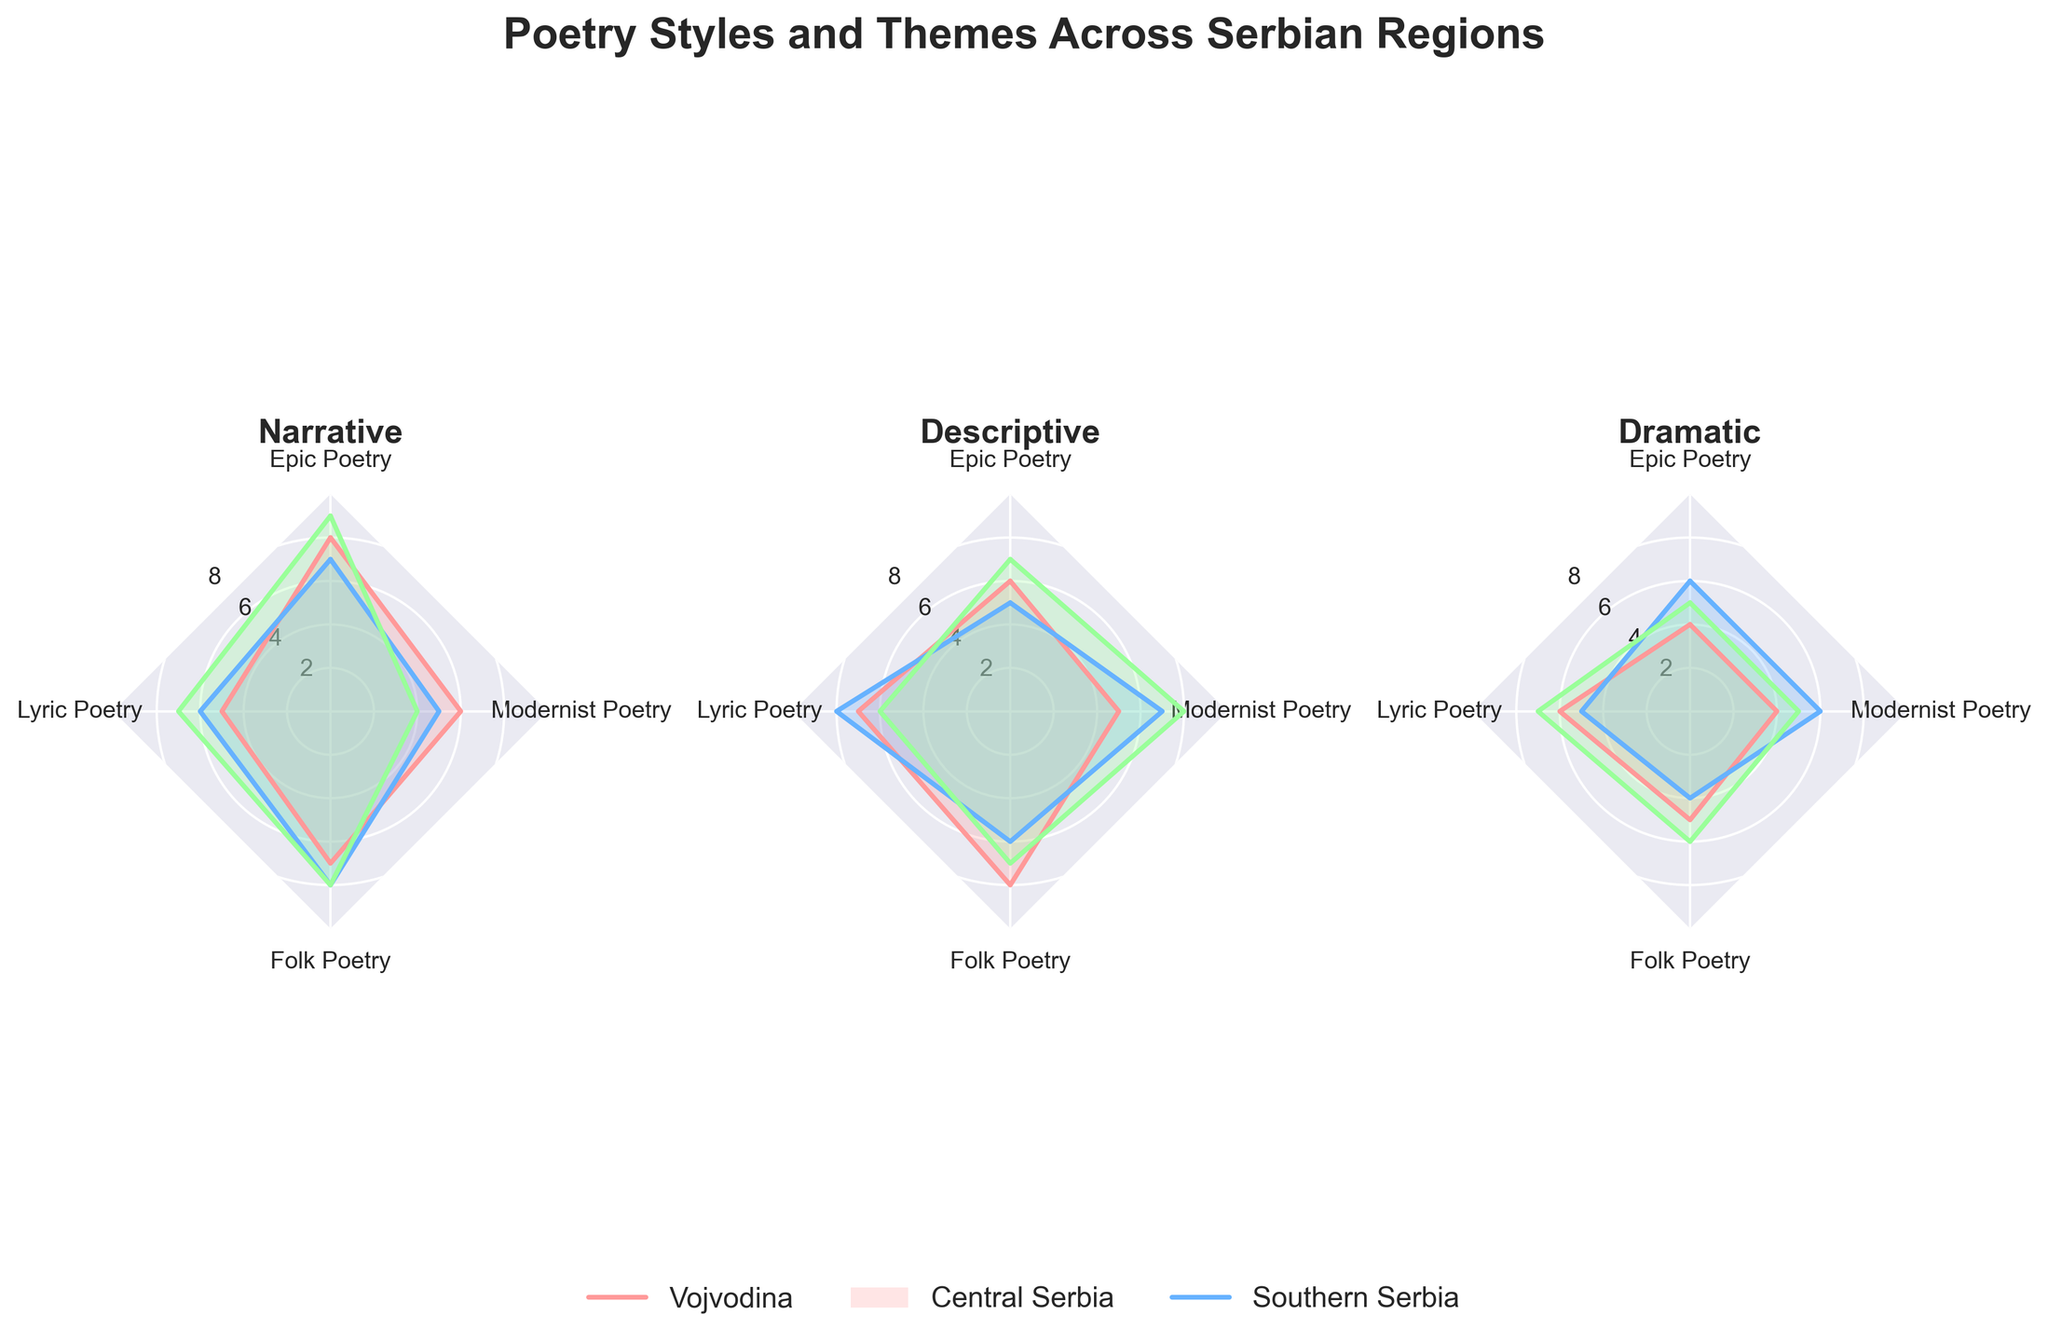How many poetry styles are compared for each region? The figure compares three different poetry styles for each region: Narrative, Descriptive, and Dramatic as seen by the number of plots (three subplots) labeled with these styles.
Answer: 3 Which region shows the highest value for Narrative Epic Poetry? For Narrative style, the subplot shows that the highest value for Epic Poetry is found in Southern Serbia, where the value is 9.
Answer: Southern Serbia What's the average value of Folk Poetry across all styles in Central Serbia? For Central Serbia, Folk Poetry values are 8 (Narrative), 6 (Descriptive), and 4 (Dramatic). The average is calculated as (8 + 6 + 4) / 3 = 6.
Answer: 6 Which poetry style has the smallest variation in values across all regions? By inspecting each subplot, Descriptive poetry style shows less variation across all regions in terms of the range of values it encompasses.
Answer: Descriptive Between Southern Serbia and Vojvodina, which region showcases a higher overall average in Dramatic Style? For Dramatic style in Southern Serbia: values are 5, 7, and 6, averaging (5 + 7 + 6) / 3 = 6. For Vojvodina: values are 4, 6, and 5, averaging (4 + 6 + 5) / 3 ≈ 5. Southern Serbia has the higher average.
Answer: Southern Serbia Which poetry style in Central Serbia has the highest Modernist Poetry value? In the Central Serbia subplot for each poetry style, the highest Modernist Poetry value is found in the Descriptive style with a value of 7.
Answer: Descriptive How are the Epic Poetry values influenced across the regions for each style? Epic Poetry values for Narrative, Descriptive, and Dramatic styles across regions show varying peaks: Highest in Southern Serbia for Narrative (9), Descriptive maintains consistency, Dramatic varies more with peaks like 5 in Southern Serbia.
Answer: Varies (highest in Southern Serbia for Narrative) Compare the Lyric Poetry values in Vojvodina for Narrative and Dramatic styles. Which one is higher? In Vojvodina, Lyric Poetry value for Narrative is 5 and for Dramatic is 6. Therefore, Dramatic style has higher Lyric Poetry value.
Answer: Dramatic What is the total value of Modernist Poetry for all styles in Vojvodina? Adding up the Modernist Poetry values in Vojvodina for each style: Narrative (6), Descriptive (5), Dramatic (4). Total is 6 + 5 + 4 = 15.
Answer: 15 